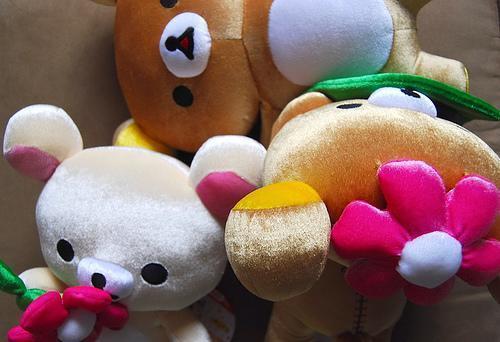How many toys are there?
Give a very brief answer. 3. How many toys are in this picture?
Give a very brief answer. 3. How many people are wearing red shoes?
Give a very brief answer. 0. 